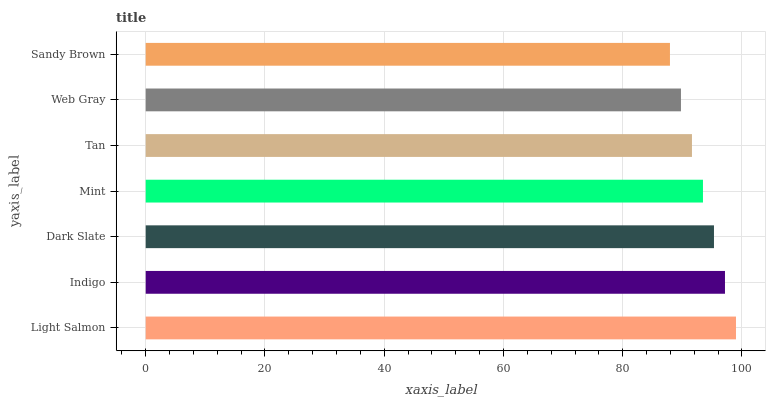Is Sandy Brown the minimum?
Answer yes or no. Yes. Is Light Salmon the maximum?
Answer yes or no. Yes. Is Indigo the minimum?
Answer yes or no. No. Is Indigo the maximum?
Answer yes or no. No. Is Light Salmon greater than Indigo?
Answer yes or no. Yes. Is Indigo less than Light Salmon?
Answer yes or no. Yes. Is Indigo greater than Light Salmon?
Answer yes or no. No. Is Light Salmon less than Indigo?
Answer yes or no. No. Is Mint the high median?
Answer yes or no. Yes. Is Mint the low median?
Answer yes or no. Yes. Is Dark Slate the high median?
Answer yes or no. No. Is Dark Slate the low median?
Answer yes or no. No. 